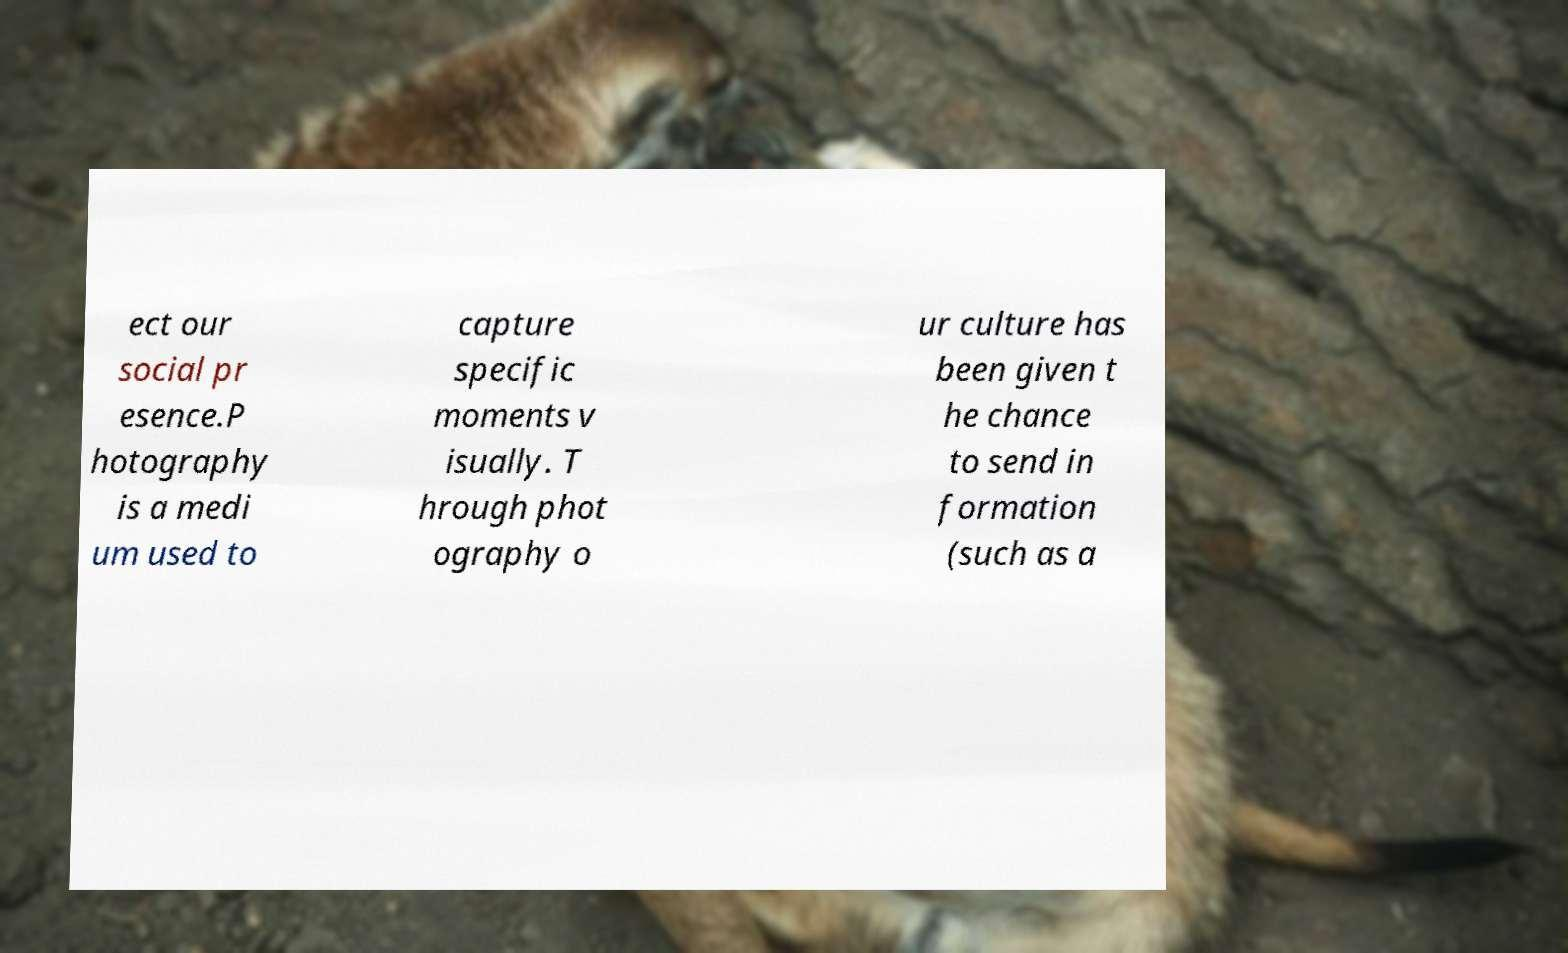Please identify and transcribe the text found in this image. ect our social pr esence.P hotography is a medi um used to capture specific moments v isually. T hrough phot ography o ur culture has been given t he chance to send in formation (such as a 